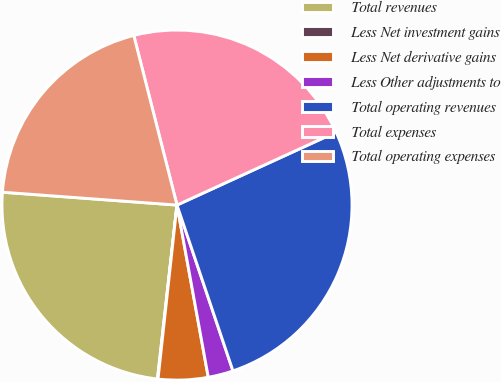<chart> <loc_0><loc_0><loc_500><loc_500><pie_chart><fcel>Total revenues<fcel>Less Net investment gains<fcel>Less Net derivative gains<fcel>Less Other adjustments to<fcel>Total operating revenues<fcel>Total expenses<fcel>Total operating expenses<nl><fcel>24.39%<fcel>0.05%<fcel>4.59%<fcel>2.32%<fcel>26.66%<fcel>22.13%<fcel>19.86%<nl></chart> 